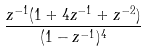<formula> <loc_0><loc_0><loc_500><loc_500>\frac { z ^ { - 1 } ( 1 + 4 z ^ { - 1 } + z ^ { - 2 } ) } { ( 1 - z ^ { - 1 } ) ^ { 4 } }</formula> 